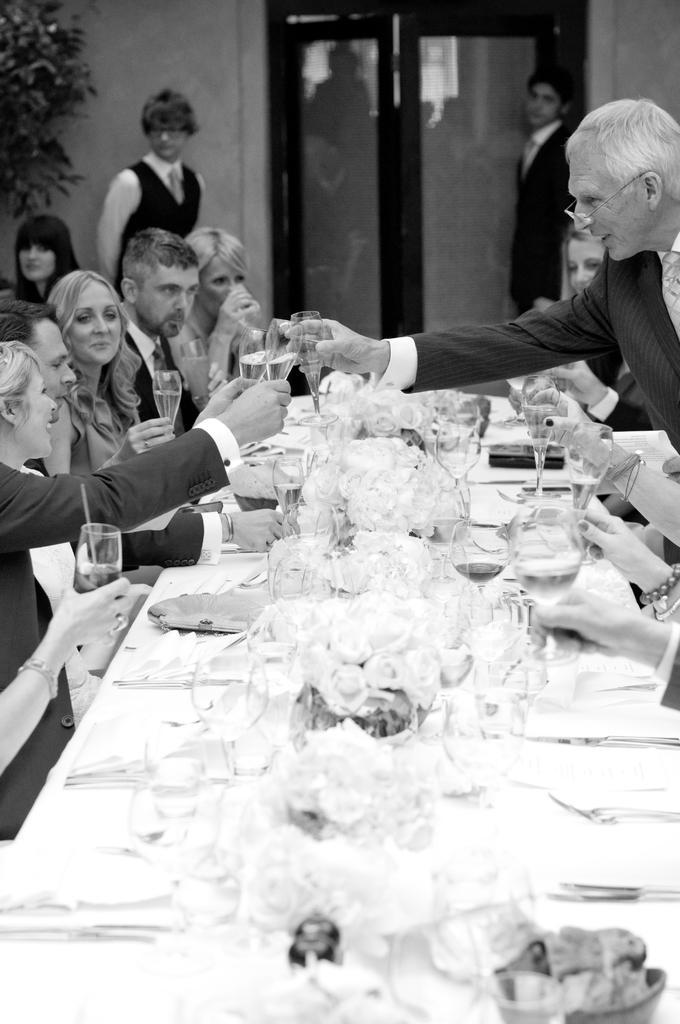Describe this image in one or two sentences. In this image I can see number of people where few of them are standing and rest all are sitting. I can also see a plant and on this table I can see number of glasses and few spoons. 